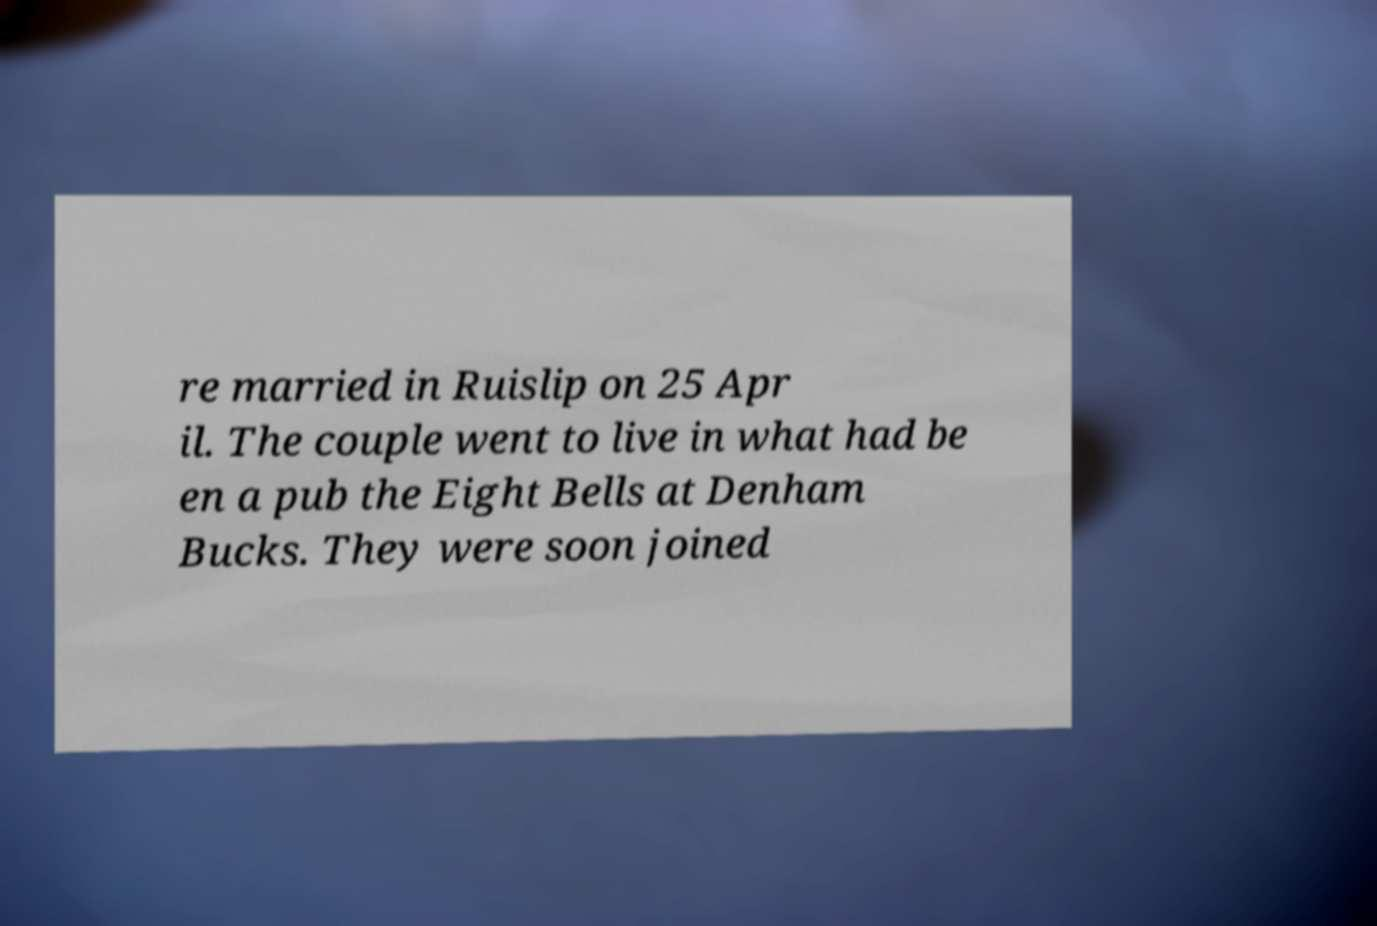Can you accurately transcribe the text from the provided image for me? re married in Ruislip on 25 Apr il. The couple went to live in what had be en a pub the Eight Bells at Denham Bucks. They were soon joined 